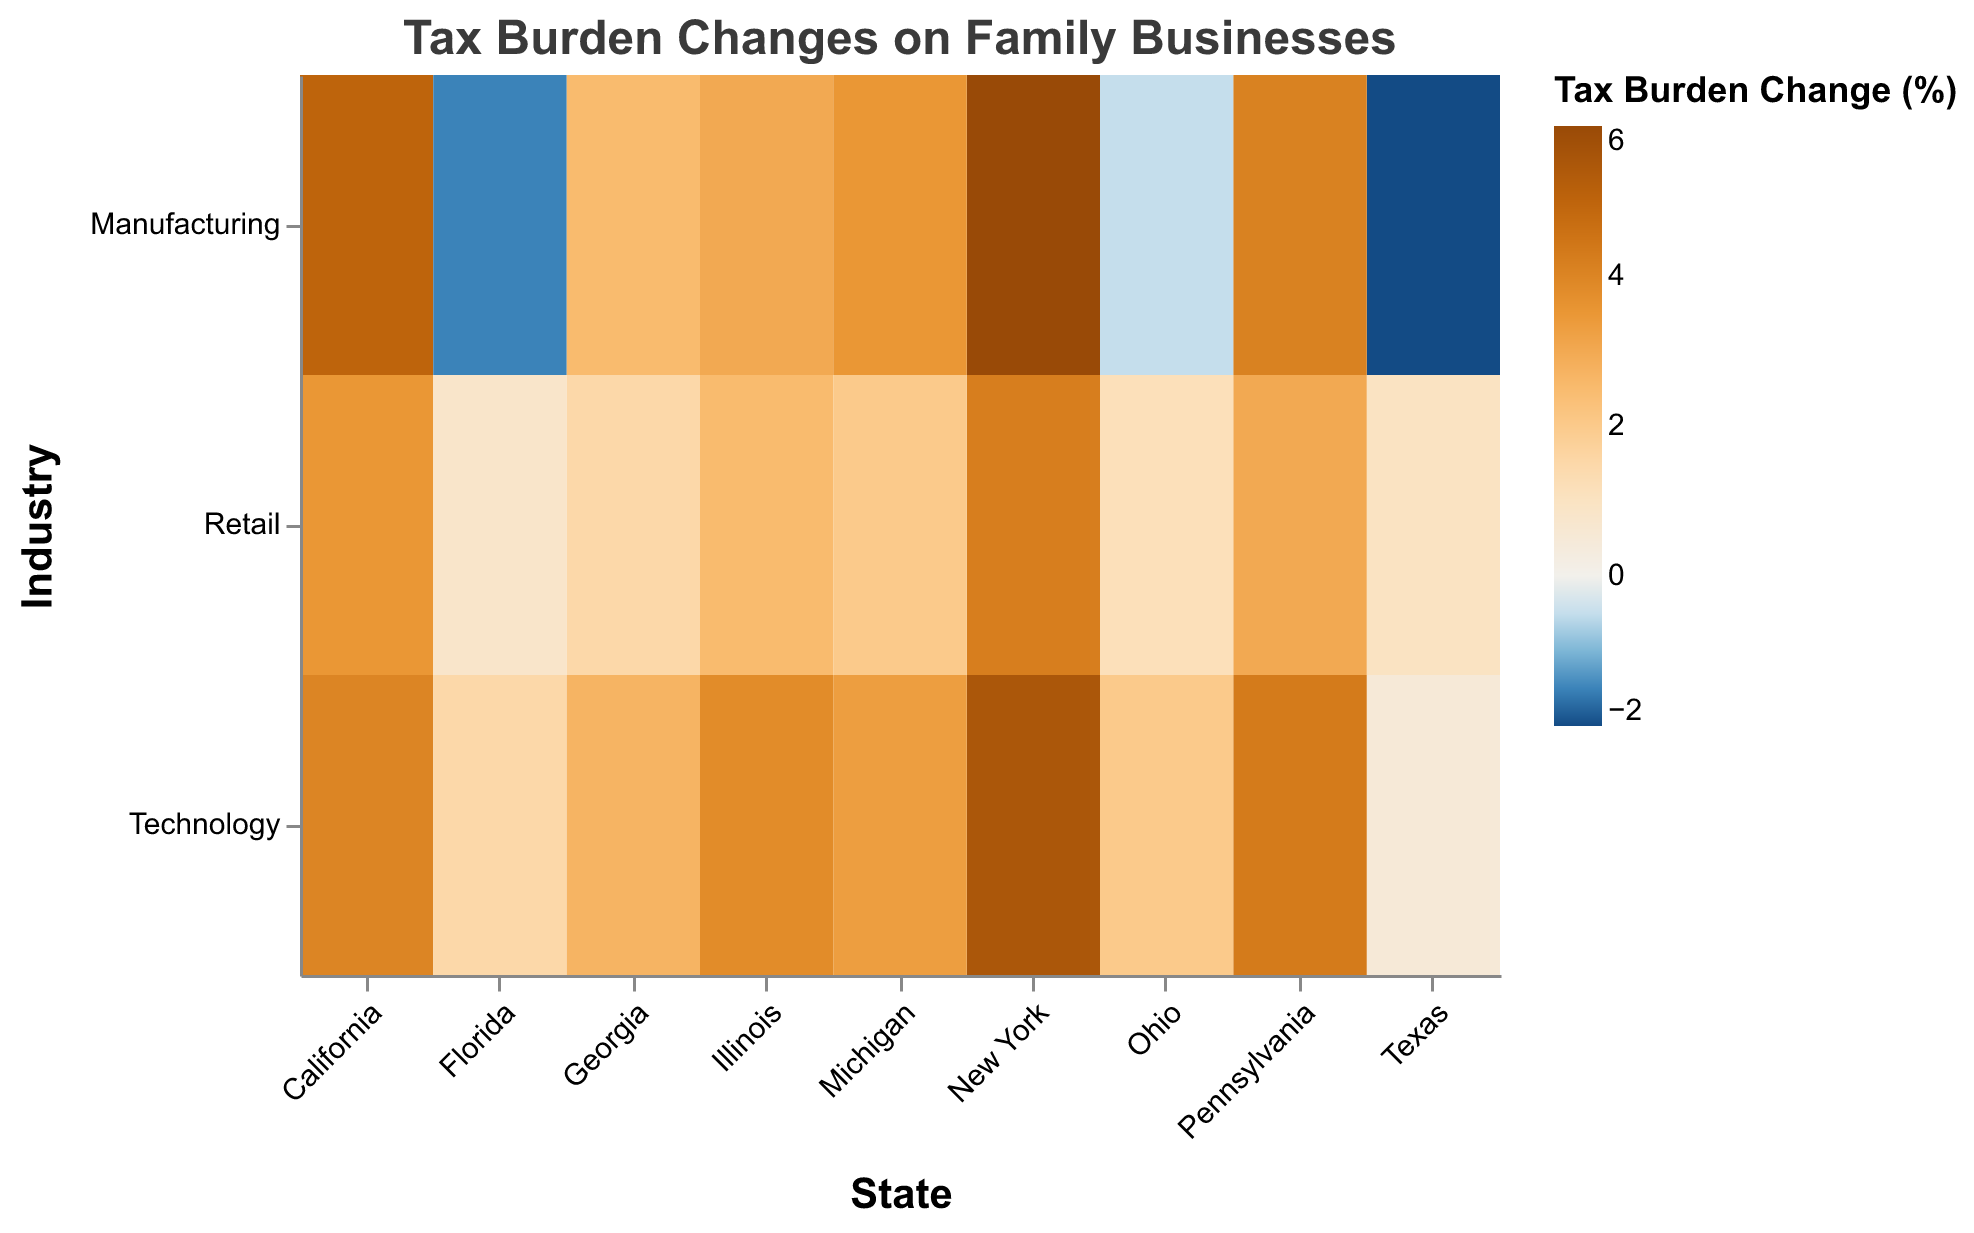What does the title of the heatmap indicate? The title of the heatmap specifies the purpose of the visualization. It indicates that the figure shows "Tax Burden Changes on Family Businesses", focusing on changes in tax burdens due to recent changes in tax laws.
Answer: Tax Burden Changes on Family Businesses Which state has the highest increase in tax burden for the manufacturing industry? To find the state with the highest increase in tax burden for the manufacturing industry, locate the column representing this industry and identify the state with the highest percentage. According to the data, New York has the highest increase with an increase of 6.0%.
Answer: New York What is the tax burden change percentage for retail businesses in Texas? To find the tax burden change percentage for retail businesses in Texas, locate the cell at the intersection of the "Texas" column and the "Retail" row. The value in that cell is 1.0%.
Answer: 1.0% Which state has a decrease in the tax burden for the technology sector? Locate the cells under the "Technology" row and find any cells with negative values. Only Texas shows a decrease in tax burden, indicating a 0.5% increase (the smallest positive change), no state shows a negative change specifically for technology.
Answer: None Which state has the smallest increase in tax burden for the retail industry? To determine the state with the smallest increase in tax burden for the retail industry, look at each cell in the "Retail" row and find the smallest positive percentage. Florida shows the smallest increase with 0.8%.
Answer: Florida Compare the tax burden changes between technology and manufacturing industries in California. Which has a higher percentage increase? To compare the tax burden changes, note the values in the "California" column for both the "Technology" and "Manufacturing" rows. For California, the percentage changes are 4.0% for Technology and 5.0% for Manufacturing. Manufacturing has a higher percentage increase.
Answer: Manufacturing Which state shows a tax burden decrease for the manufacturing industry and by how much? To find the state(s) with a tax burden decrease for the manufacturing industry, locate cells with negative values in the "Manufacturing" row. Texas shows a decrease of -2.0%, and Florida shows a decrease of -1.5%.
Answer: Texas and Florida Calculate the average tax burden change for all industries in Georgia. Add up the tax burden changes for all industries in Georgia and divide by the number of industries: (2.5 + 1.5 + 2.7) / 3. The sum is 6.7, and average is 6.7 / 3.
Answer: 2.23 Which industry in New York has the lowest increase in tax burden? For New York, compare the tax burden change percentages across different industries. The values are 6.0% for Manufacturing, 4.2% for Retail, and 5.5% for Technology. Retail has the lowest increase.
Answer: Retail Is there any state where the tax burden change for all industries is positive? For each state, check if all values for the industries are positive; these states are California, New York, Illinois, Pennsylvania, and Michigan.
Answer: Yes 